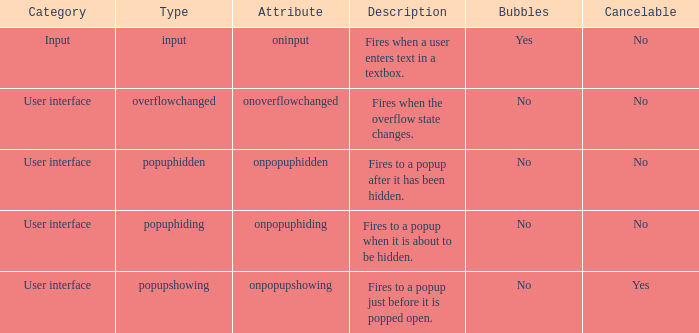Which characteristic has "cancelable" set to yes? Onpopupshowing. 